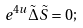Convert formula to latex. <formula><loc_0><loc_0><loc_500><loc_500>e ^ { 4 u } \tilde { \Delta } \tilde { S } = 0 ;</formula> 